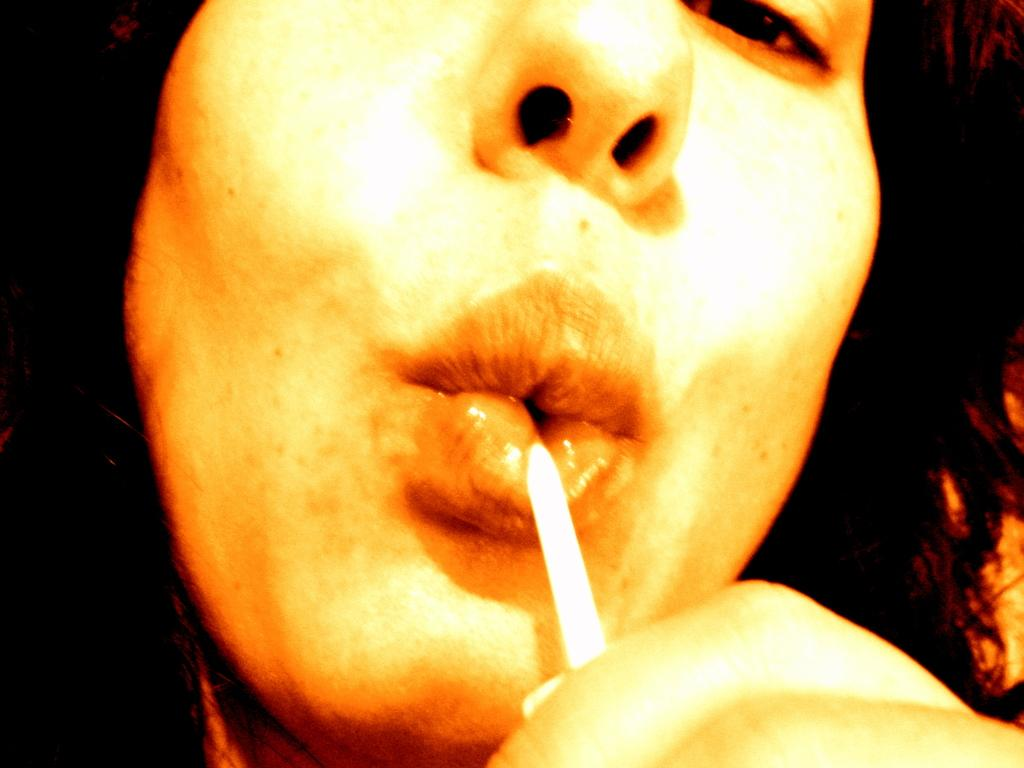What can be seen in the image? There is a person in the image. What is the person doing in the image? The person is holding an object. Can you describe the background of the image? The background of the image is dark. What is the person's income in the image? There is no information about the person's income in the image. What degree does the person have in the image? There is no information about the person's degree in the image. 